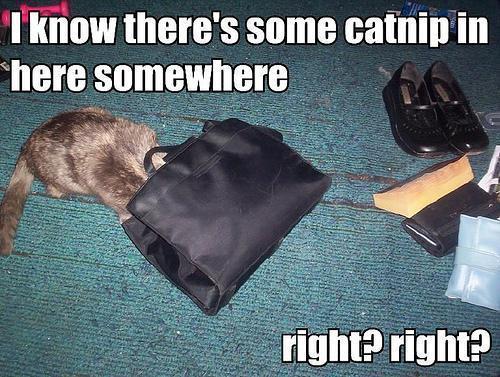How many people are wearing red shirt?
Give a very brief answer. 0. 